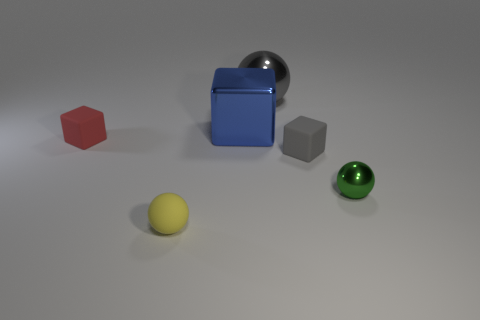Add 4 green shiny spheres. How many objects exist? 10 Subtract all large cyan things. Subtract all big gray spheres. How many objects are left? 5 Add 2 metallic spheres. How many metallic spheres are left? 4 Add 2 spheres. How many spheres exist? 5 Subtract 0 purple spheres. How many objects are left? 6 